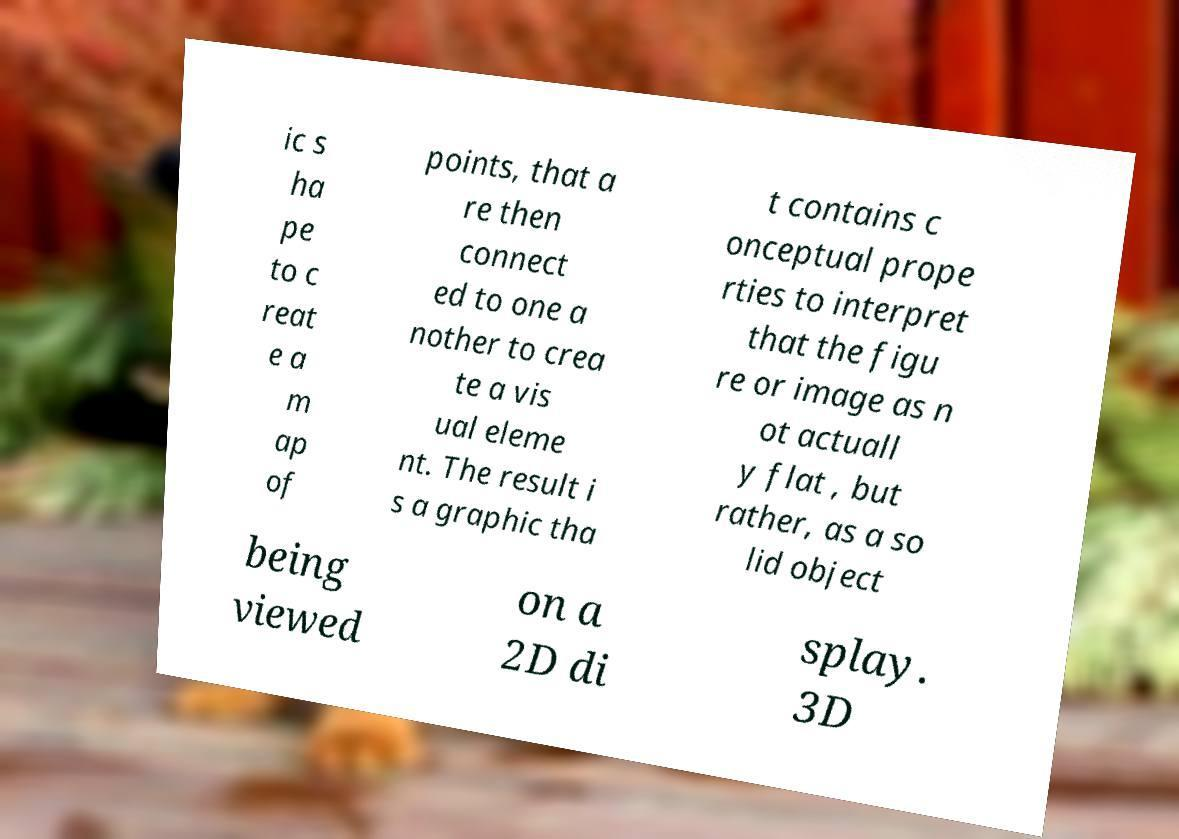Please read and relay the text visible in this image. What does it say? ic s ha pe to c reat e a m ap of points, that a re then connect ed to one a nother to crea te a vis ual eleme nt. The result i s a graphic tha t contains c onceptual prope rties to interpret that the figu re or image as n ot actuall y flat , but rather, as a so lid object being viewed on a 2D di splay. 3D 